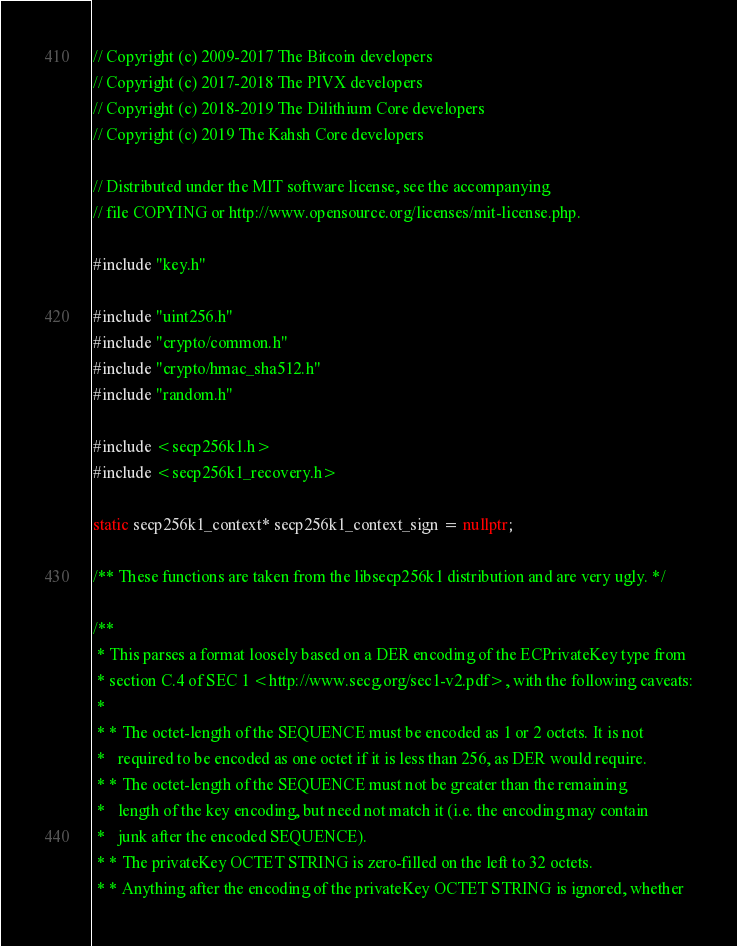<code> <loc_0><loc_0><loc_500><loc_500><_C++_>// Copyright (c) 2009-2017 The Bitcoin developers
// Copyright (c) 2017-2018 The PIVX developers
// Copyright (c) 2018-2019 The Dilithium Core developers
// Copyright (c) 2019 The Kahsh Core developers

// Distributed under the MIT software license, see the accompanying
// file COPYING or http://www.opensource.org/licenses/mit-license.php.

#include "key.h"

#include "uint256.h"
#include "crypto/common.h"
#include "crypto/hmac_sha512.h"
#include "random.h"

#include <secp256k1.h>
#include <secp256k1_recovery.h>

static secp256k1_context* secp256k1_context_sign = nullptr;

/** These functions are taken from the libsecp256k1 distribution and are very ugly. */

/**
 * This parses a format loosely based on a DER encoding of the ECPrivateKey type from
 * section C.4 of SEC 1 <http://www.secg.org/sec1-v2.pdf>, with the following caveats:
 *
 * * The octet-length of the SEQUENCE must be encoded as 1 or 2 octets. It is not
 *   required to be encoded as one octet if it is less than 256, as DER would require.
 * * The octet-length of the SEQUENCE must not be greater than the remaining
 *   length of the key encoding, but need not match it (i.e. the encoding may contain
 *   junk after the encoded SEQUENCE).
 * * The privateKey OCTET STRING is zero-filled on the left to 32 octets.
 * * Anything after the encoding of the privateKey OCTET STRING is ignored, whether</code> 